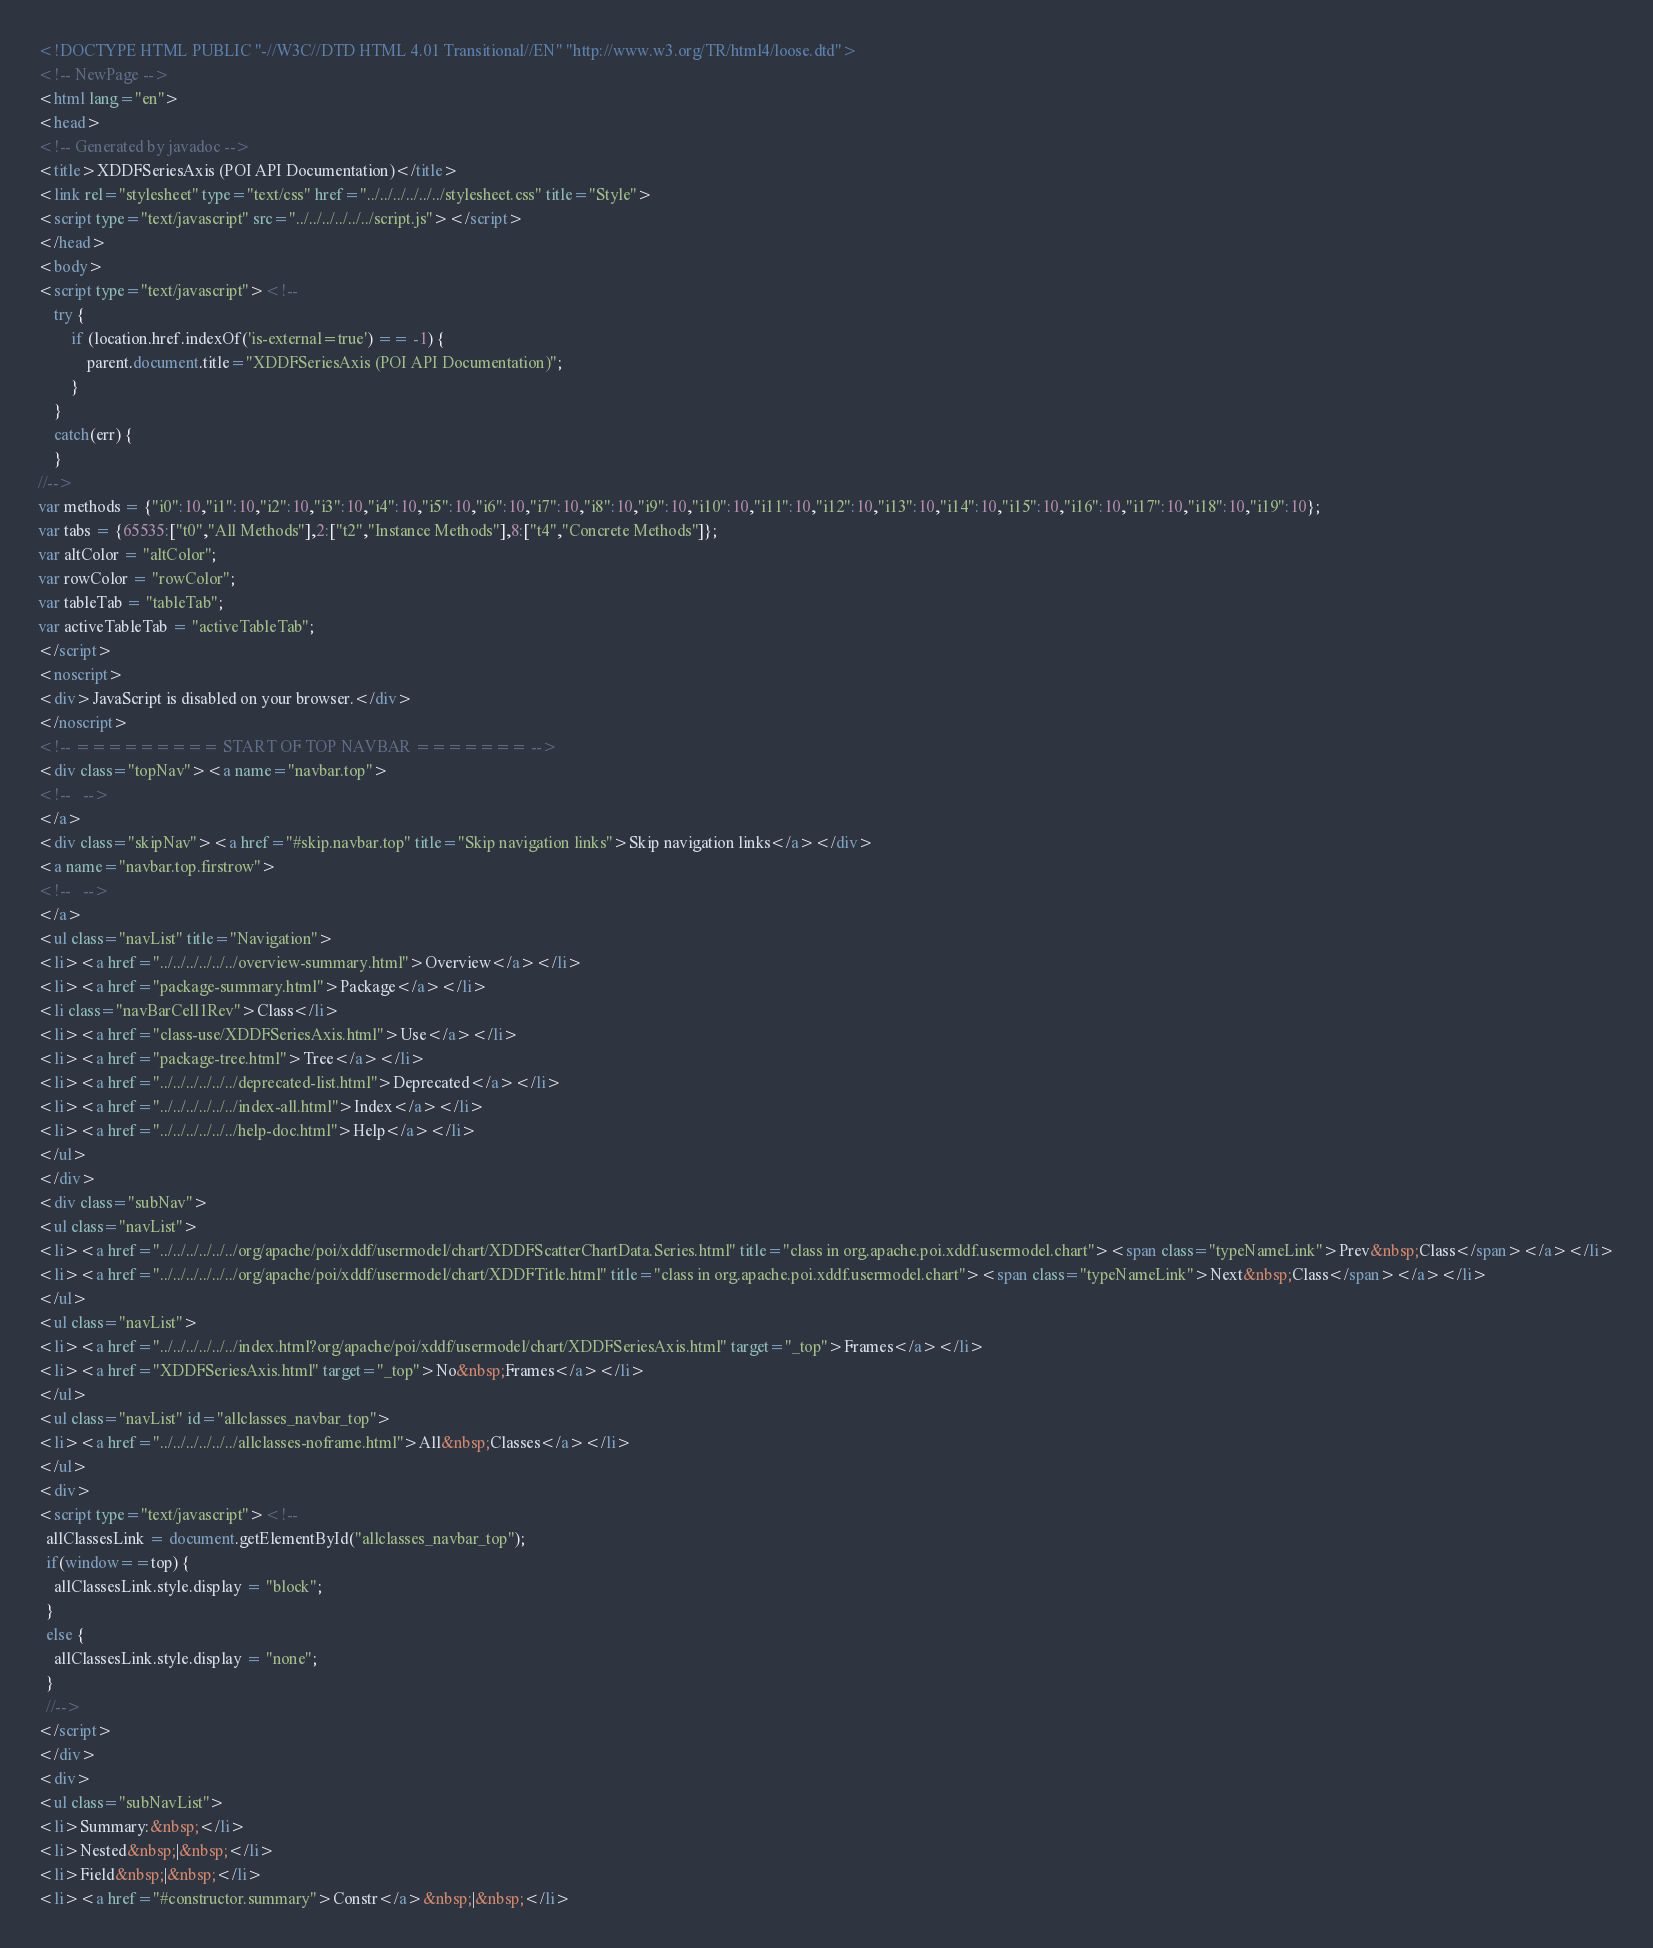Convert code to text. <code><loc_0><loc_0><loc_500><loc_500><_HTML_><!DOCTYPE HTML PUBLIC "-//W3C//DTD HTML 4.01 Transitional//EN" "http://www.w3.org/TR/html4/loose.dtd">
<!-- NewPage -->
<html lang="en">
<head>
<!-- Generated by javadoc -->
<title>XDDFSeriesAxis (POI API Documentation)</title>
<link rel="stylesheet" type="text/css" href="../../../../../../stylesheet.css" title="Style">
<script type="text/javascript" src="../../../../../../script.js"></script>
</head>
<body>
<script type="text/javascript"><!--
    try {
        if (location.href.indexOf('is-external=true') == -1) {
            parent.document.title="XDDFSeriesAxis (POI API Documentation)";
        }
    }
    catch(err) {
    }
//-->
var methods = {"i0":10,"i1":10,"i2":10,"i3":10,"i4":10,"i5":10,"i6":10,"i7":10,"i8":10,"i9":10,"i10":10,"i11":10,"i12":10,"i13":10,"i14":10,"i15":10,"i16":10,"i17":10,"i18":10,"i19":10};
var tabs = {65535:["t0","All Methods"],2:["t2","Instance Methods"],8:["t4","Concrete Methods"]};
var altColor = "altColor";
var rowColor = "rowColor";
var tableTab = "tableTab";
var activeTableTab = "activeTableTab";
</script>
<noscript>
<div>JavaScript is disabled on your browser.</div>
</noscript>
<!-- ========= START OF TOP NAVBAR ======= -->
<div class="topNav"><a name="navbar.top">
<!--   -->
</a>
<div class="skipNav"><a href="#skip.navbar.top" title="Skip navigation links">Skip navigation links</a></div>
<a name="navbar.top.firstrow">
<!--   -->
</a>
<ul class="navList" title="Navigation">
<li><a href="../../../../../../overview-summary.html">Overview</a></li>
<li><a href="package-summary.html">Package</a></li>
<li class="navBarCell1Rev">Class</li>
<li><a href="class-use/XDDFSeriesAxis.html">Use</a></li>
<li><a href="package-tree.html">Tree</a></li>
<li><a href="../../../../../../deprecated-list.html">Deprecated</a></li>
<li><a href="../../../../../../index-all.html">Index</a></li>
<li><a href="../../../../../../help-doc.html">Help</a></li>
</ul>
</div>
<div class="subNav">
<ul class="navList">
<li><a href="../../../../../../org/apache/poi/xddf/usermodel/chart/XDDFScatterChartData.Series.html" title="class in org.apache.poi.xddf.usermodel.chart"><span class="typeNameLink">Prev&nbsp;Class</span></a></li>
<li><a href="../../../../../../org/apache/poi/xddf/usermodel/chart/XDDFTitle.html" title="class in org.apache.poi.xddf.usermodel.chart"><span class="typeNameLink">Next&nbsp;Class</span></a></li>
</ul>
<ul class="navList">
<li><a href="../../../../../../index.html?org/apache/poi/xddf/usermodel/chart/XDDFSeriesAxis.html" target="_top">Frames</a></li>
<li><a href="XDDFSeriesAxis.html" target="_top">No&nbsp;Frames</a></li>
</ul>
<ul class="navList" id="allclasses_navbar_top">
<li><a href="../../../../../../allclasses-noframe.html">All&nbsp;Classes</a></li>
</ul>
<div>
<script type="text/javascript"><!--
  allClassesLink = document.getElementById("allclasses_navbar_top");
  if(window==top) {
    allClassesLink.style.display = "block";
  }
  else {
    allClassesLink.style.display = "none";
  }
  //-->
</script>
</div>
<div>
<ul class="subNavList">
<li>Summary:&nbsp;</li>
<li>Nested&nbsp;|&nbsp;</li>
<li>Field&nbsp;|&nbsp;</li>
<li><a href="#constructor.summary">Constr</a>&nbsp;|&nbsp;</li></code> 